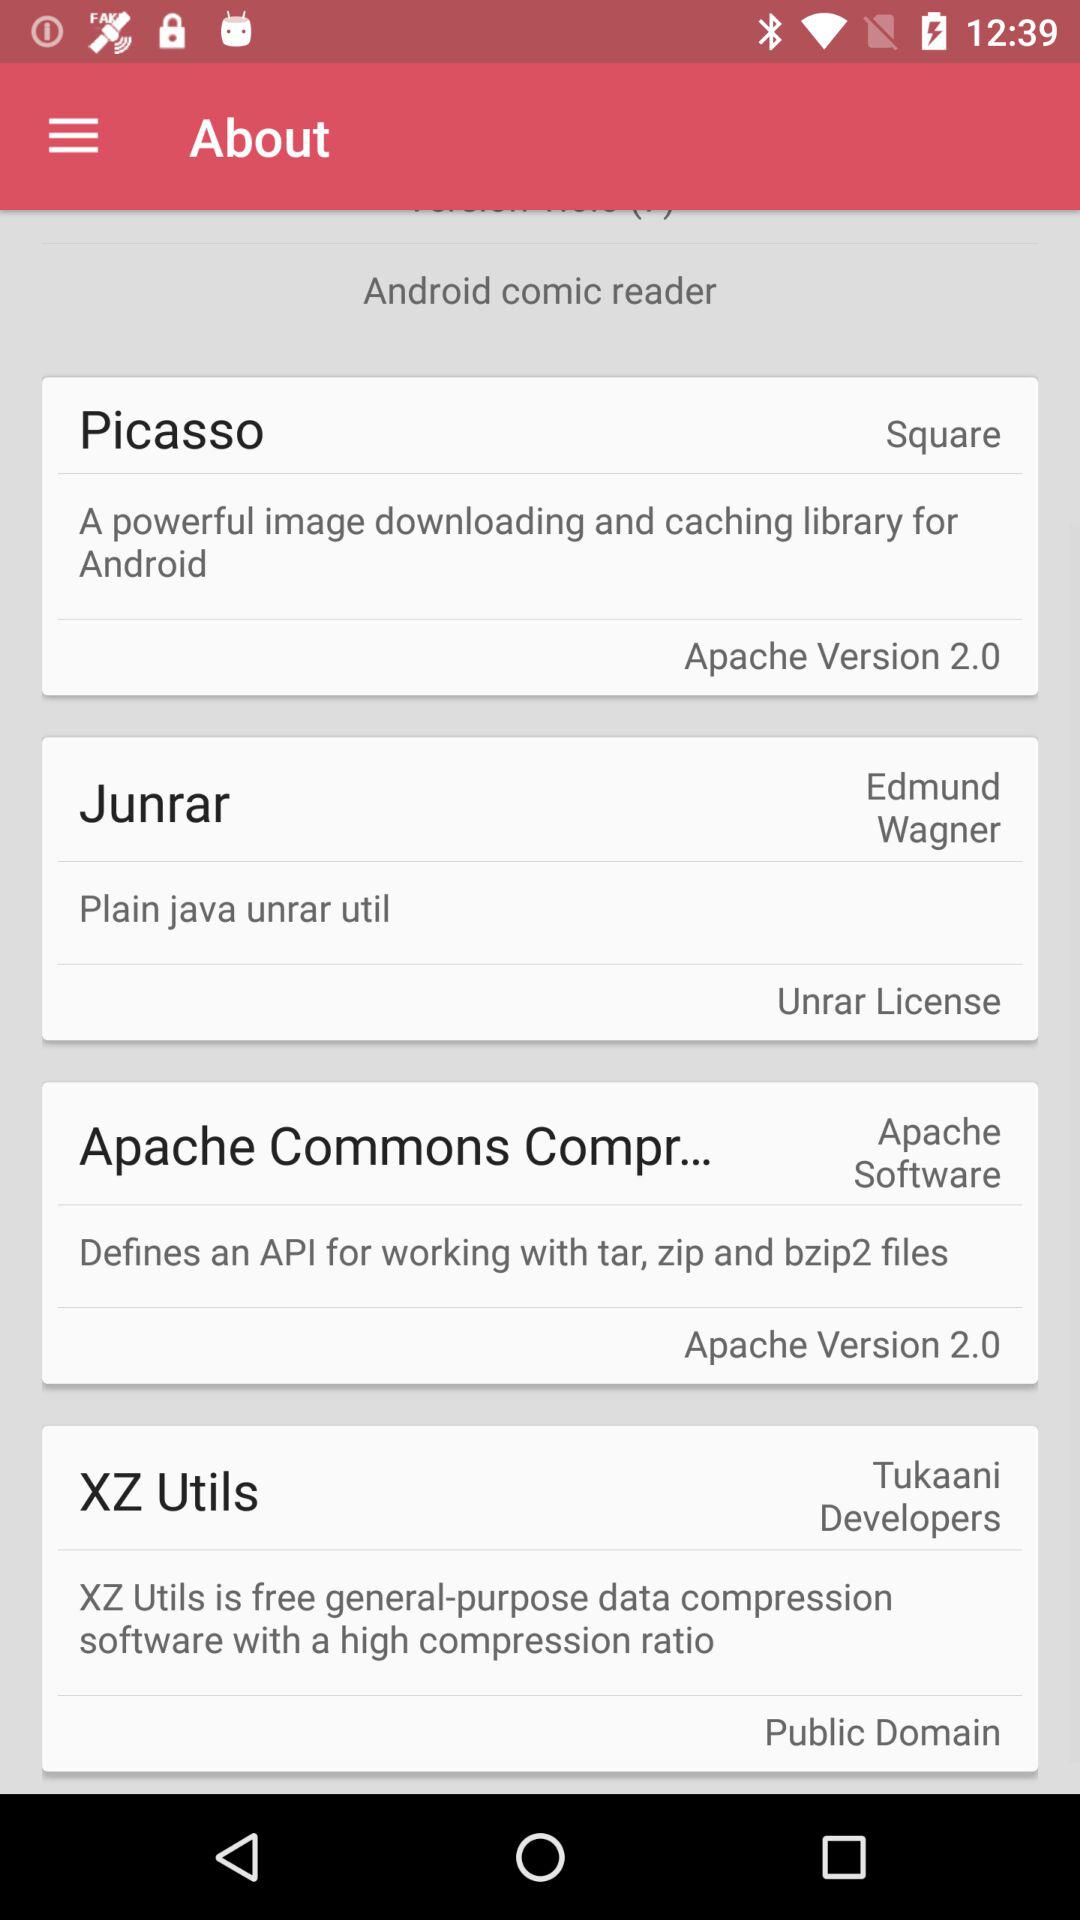What is the Apache version of Picasso? The Apache version of Picasso is 2.0. 